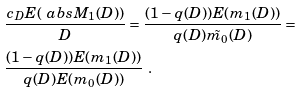Convert formula to latex. <formula><loc_0><loc_0><loc_500><loc_500>& \frac { c _ { D } E ( \ a b s { M _ { 1 } ( D ) } ) } { D } = \frac { ( 1 - q ( D ) ) E ( m _ { 1 } ( D ) ) } { q ( D ) \tilde { m _ { 0 } } ( D ) } = \\ & \frac { ( 1 - q ( D ) ) E ( m _ { 1 } ( D ) ) } { q ( D ) E ( { m _ { 0 } } ( D ) ) } \ .</formula> 